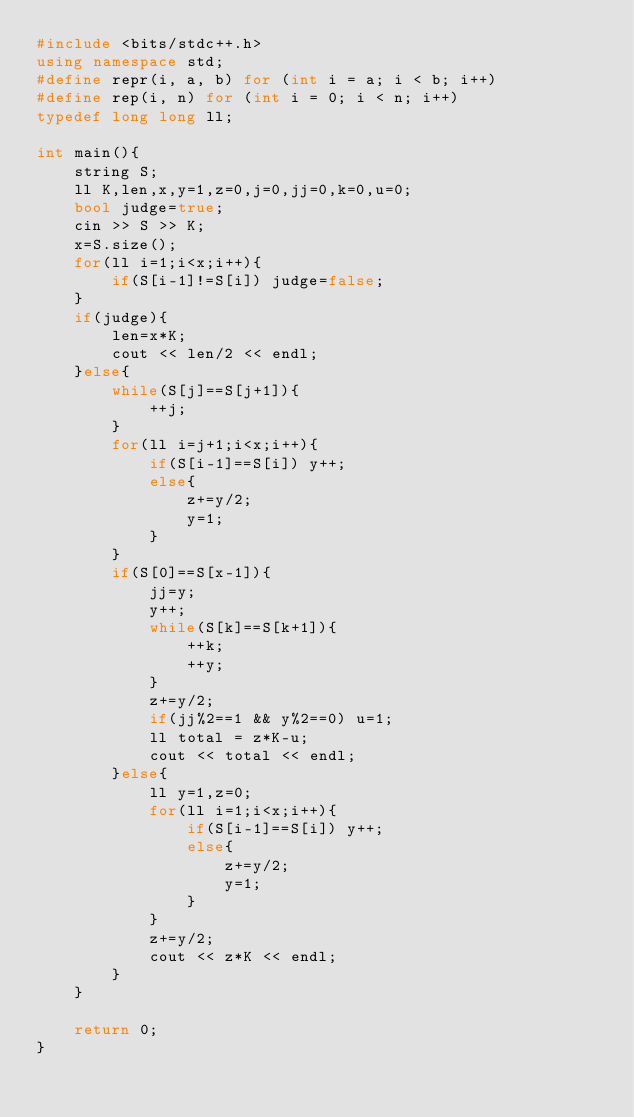<code> <loc_0><loc_0><loc_500><loc_500><_C++_>#include <bits/stdc++.h>
using namespace std;
#define repr(i, a, b) for (int i = a; i < b; i++)
#define rep(i, n) for (int i = 0; i < n; i++)
typedef long long ll;

int main(){
    string S;
    ll K,len,x,y=1,z=0,j=0,jj=0,k=0,u=0;
    bool judge=true;
    cin >> S >> K;
    x=S.size();
    for(ll i=1;i<x;i++){
        if(S[i-1]!=S[i]) judge=false;
    }
    if(judge){
        len=x*K;
        cout << len/2 << endl;
    }else{
        while(S[j]==S[j+1]){
            ++j;
        }
        for(ll i=j+1;i<x;i++){
            if(S[i-1]==S[i]) y++;
            else{
                z+=y/2;
                y=1;
            }
        }
        if(S[0]==S[x-1]){
            jj=y;
            y++;
            while(S[k]==S[k+1]){
                ++k;
                ++y;
            }
            z+=y/2;
            if(jj%2==1 && y%2==0) u=1;
            ll total = z*K-u;
            cout << total << endl;
        }else{
            ll y=1,z=0;
            for(ll i=1;i<x;i++){
                if(S[i-1]==S[i]) y++;
                else{
                    z+=y/2;
                    y=1;
                }
            }
            z+=y/2;
            cout << z*K << endl;
        }
    }

    return 0;
}
</code> 